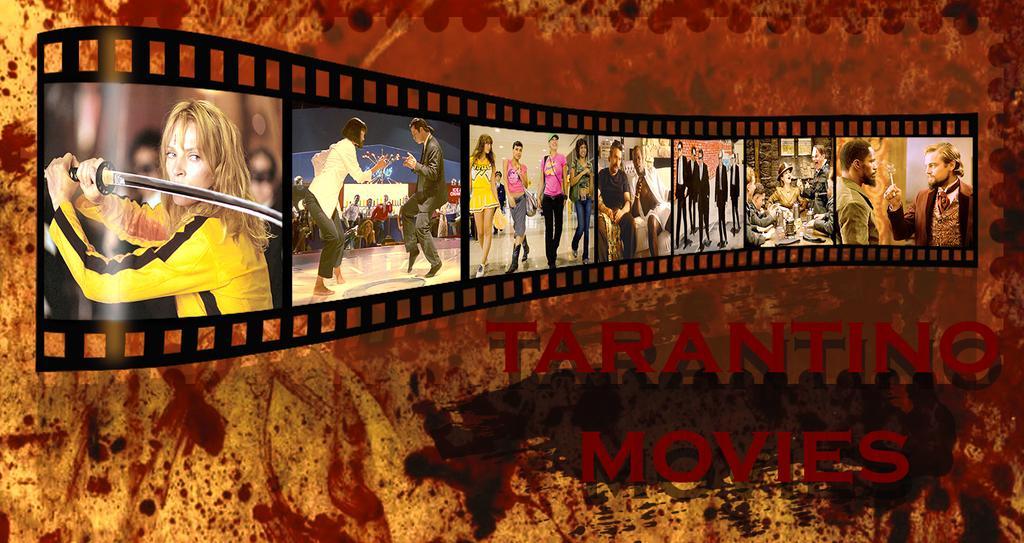Please provide a concise description of this image. This is an edited picture. In this picture we can see the people, reel. We can see there is some information. 